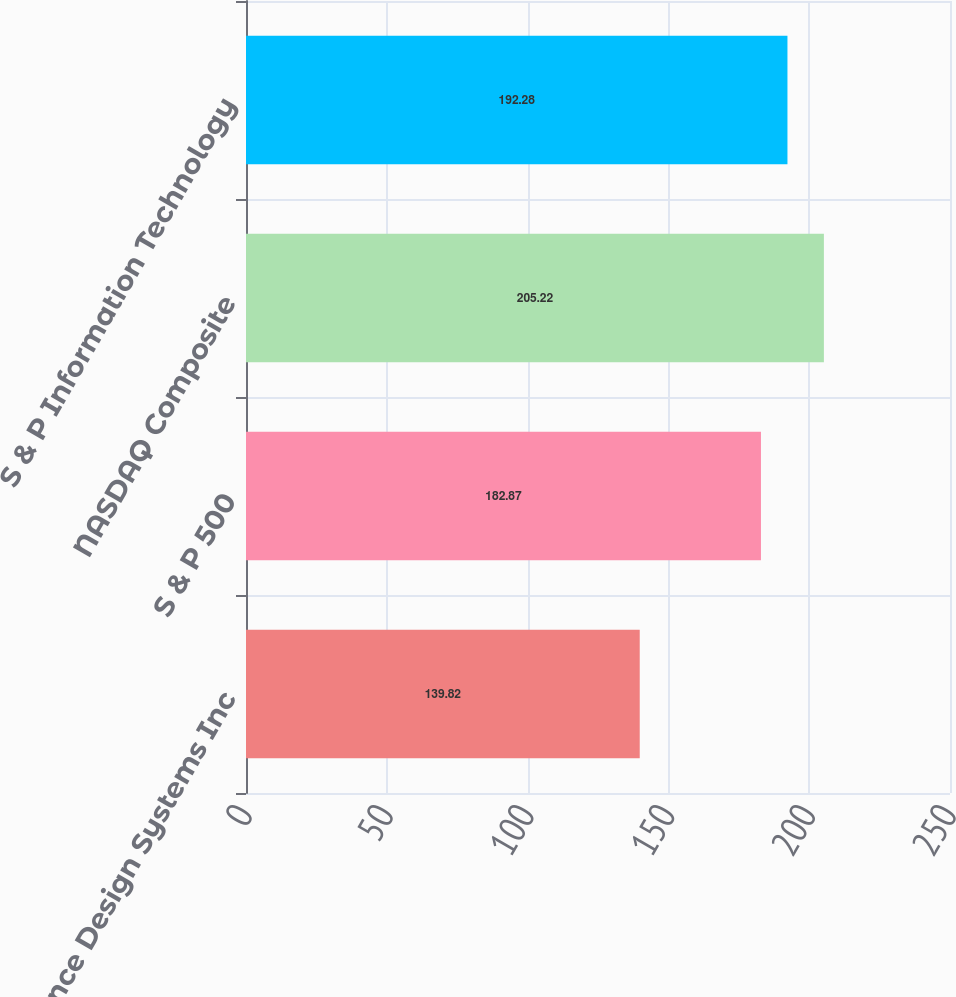Convert chart to OTSL. <chart><loc_0><loc_0><loc_500><loc_500><bar_chart><fcel>Cadence Design Systems Inc<fcel>S & P 500<fcel>NASDAQ Composite<fcel>S & P Information Technology<nl><fcel>139.82<fcel>182.87<fcel>205.22<fcel>192.28<nl></chart> 